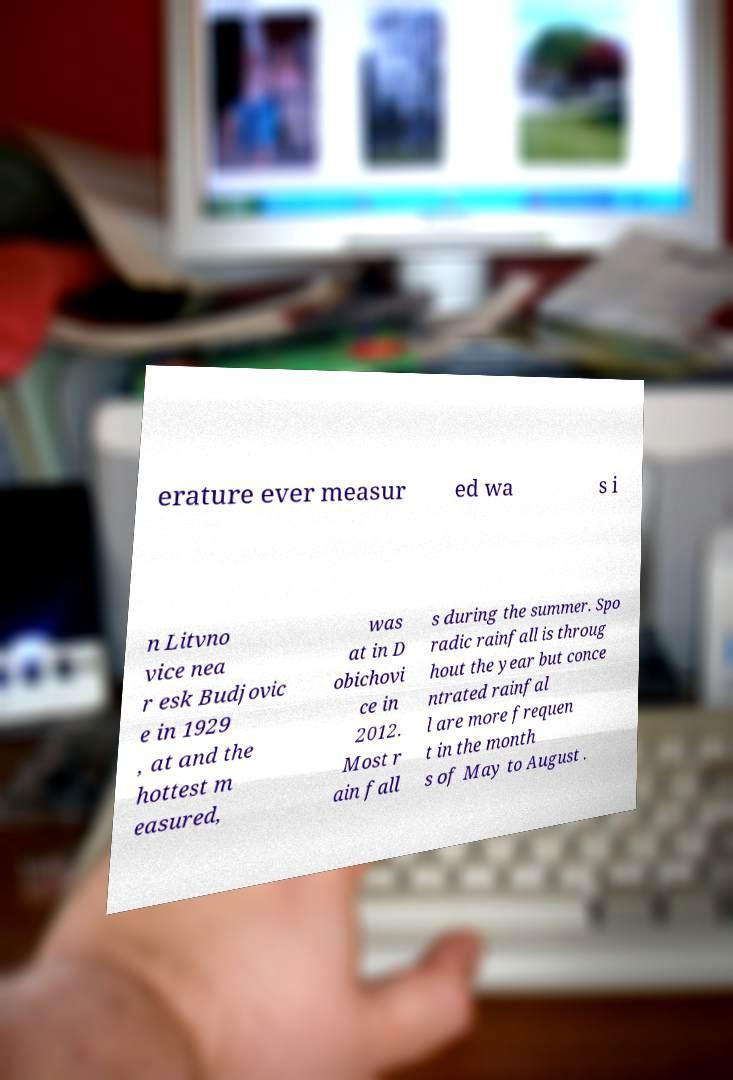Please read and relay the text visible in this image. What does it say? erature ever measur ed wa s i n Litvno vice nea r esk Budjovic e in 1929 , at and the hottest m easured, was at in D obichovi ce in 2012. Most r ain fall s during the summer. Spo radic rainfall is throug hout the year but conce ntrated rainfal l are more frequen t in the month s of May to August . 